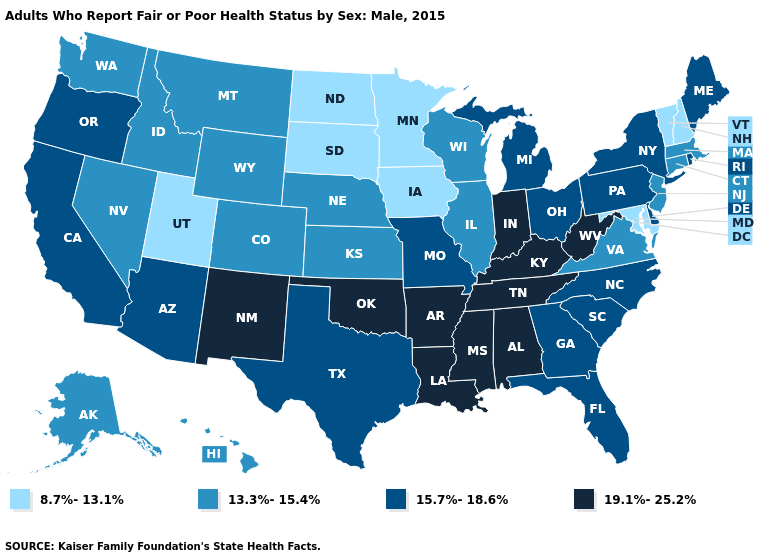What is the highest value in the USA?
Be succinct. 19.1%-25.2%. Is the legend a continuous bar?
Be succinct. No. What is the value of Massachusetts?
Short answer required. 13.3%-15.4%. Which states have the highest value in the USA?
Be succinct. Alabama, Arkansas, Indiana, Kentucky, Louisiana, Mississippi, New Mexico, Oklahoma, Tennessee, West Virginia. Name the states that have a value in the range 13.3%-15.4%?
Answer briefly. Alaska, Colorado, Connecticut, Hawaii, Idaho, Illinois, Kansas, Massachusetts, Montana, Nebraska, Nevada, New Jersey, Virginia, Washington, Wisconsin, Wyoming. What is the value of New Jersey?
Concise answer only. 13.3%-15.4%. Name the states that have a value in the range 19.1%-25.2%?
Give a very brief answer. Alabama, Arkansas, Indiana, Kentucky, Louisiana, Mississippi, New Mexico, Oklahoma, Tennessee, West Virginia. Does the first symbol in the legend represent the smallest category?
Write a very short answer. Yes. What is the highest value in states that border Idaho?
Give a very brief answer. 15.7%-18.6%. Name the states that have a value in the range 15.7%-18.6%?
Quick response, please. Arizona, California, Delaware, Florida, Georgia, Maine, Michigan, Missouri, New York, North Carolina, Ohio, Oregon, Pennsylvania, Rhode Island, South Carolina, Texas. Name the states that have a value in the range 19.1%-25.2%?
Short answer required. Alabama, Arkansas, Indiana, Kentucky, Louisiana, Mississippi, New Mexico, Oklahoma, Tennessee, West Virginia. Among the states that border Florida , does Georgia have the highest value?
Quick response, please. No. What is the value of Vermont?
Answer briefly. 8.7%-13.1%. Does the first symbol in the legend represent the smallest category?
Give a very brief answer. Yes. Name the states that have a value in the range 15.7%-18.6%?
Give a very brief answer. Arizona, California, Delaware, Florida, Georgia, Maine, Michigan, Missouri, New York, North Carolina, Ohio, Oregon, Pennsylvania, Rhode Island, South Carolina, Texas. 